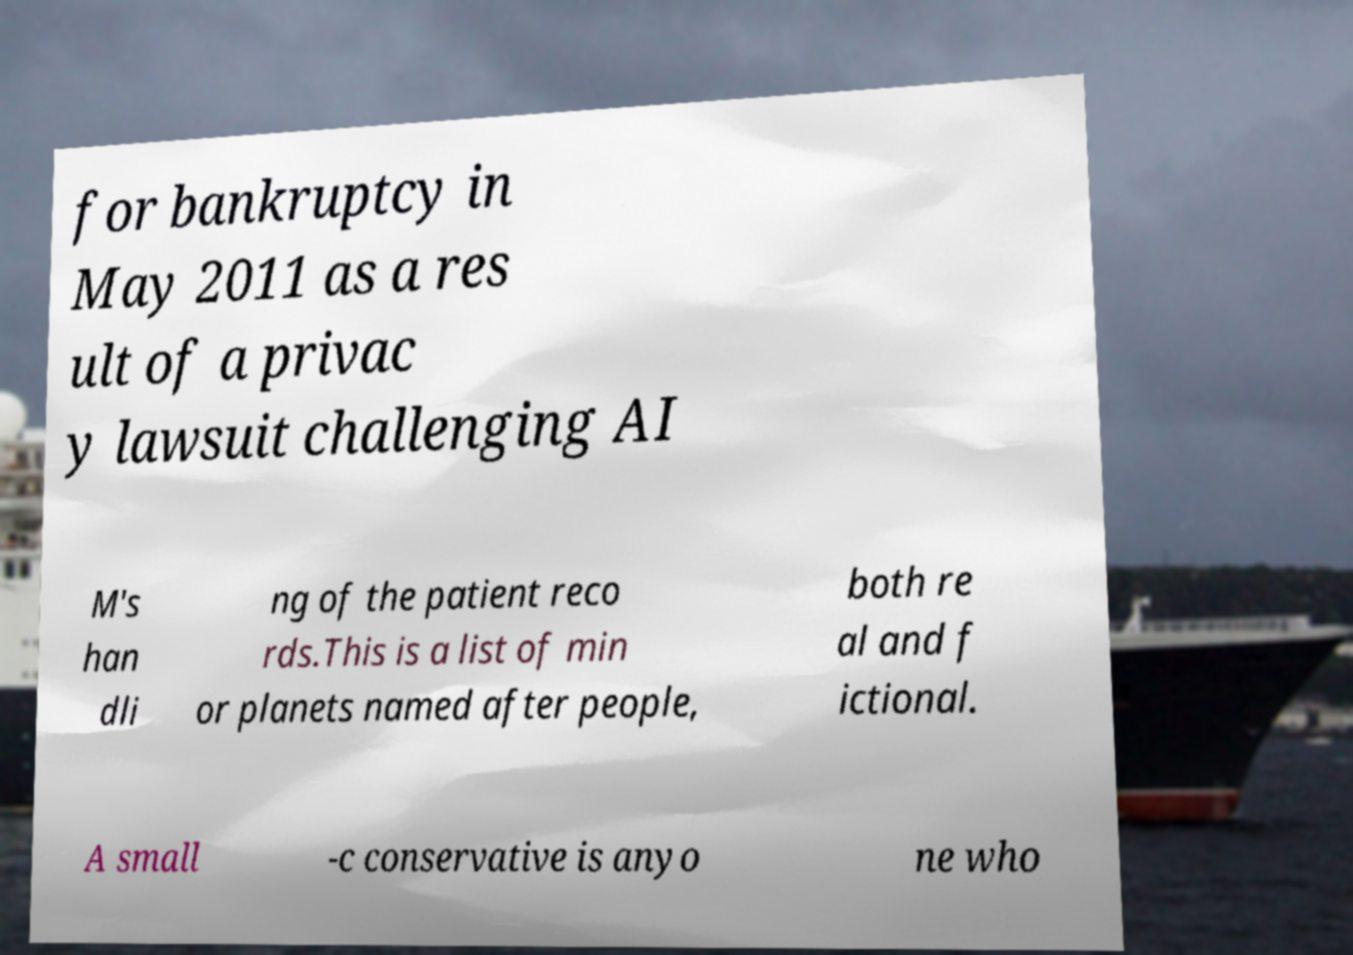Could you extract and type out the text from this image? for bankruptcy in May 2011 as a res ult of a privac y lawsuit challenging AI M's han dli ng of the patient reco rds.This is a list of min or planets named after people, both re al and f ictional. A small -c conservative is anyo ne who 